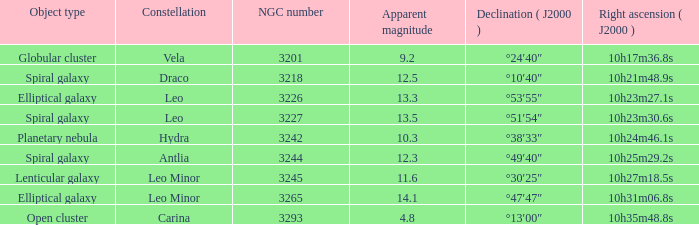What is the total of Apparent magnitudes for an NGC number larger than 3293? None. 